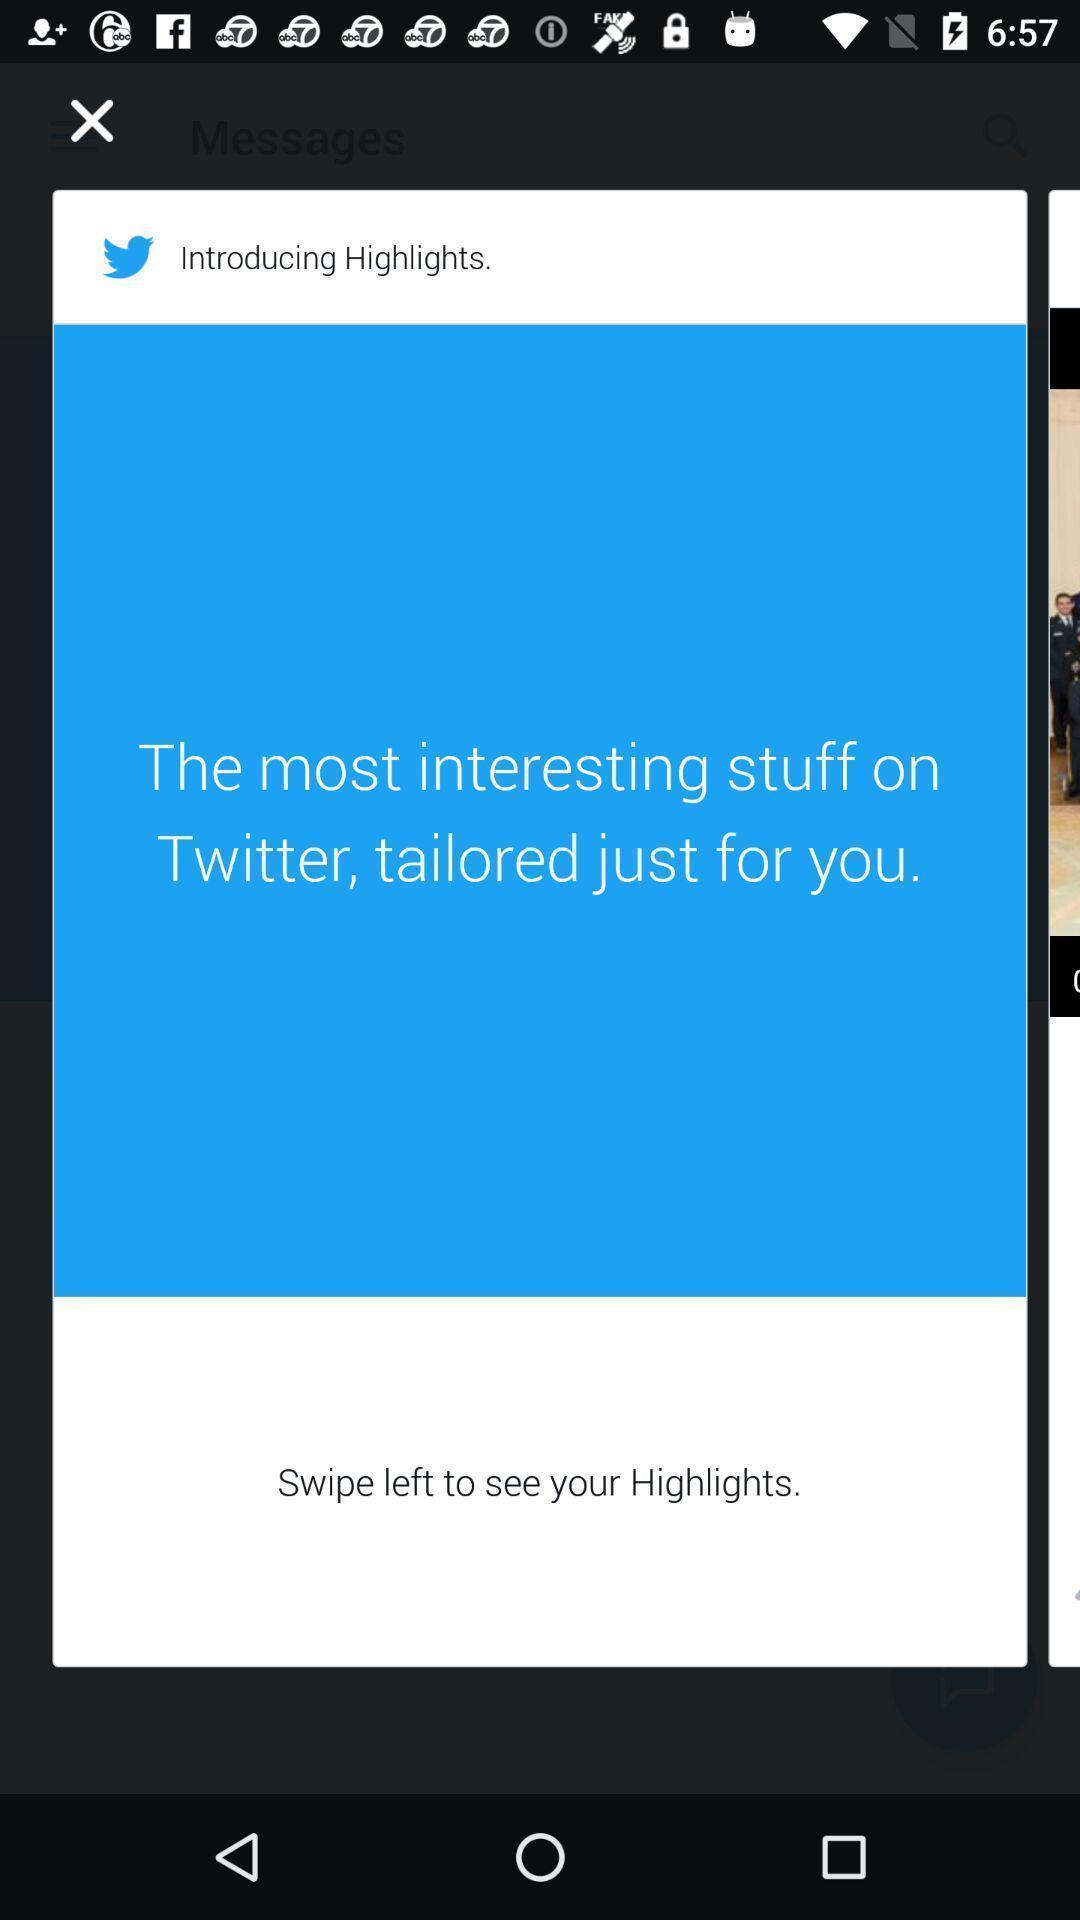Describe the visual elements of this screenshot. Pop up page displaying highlights of a social media app. 